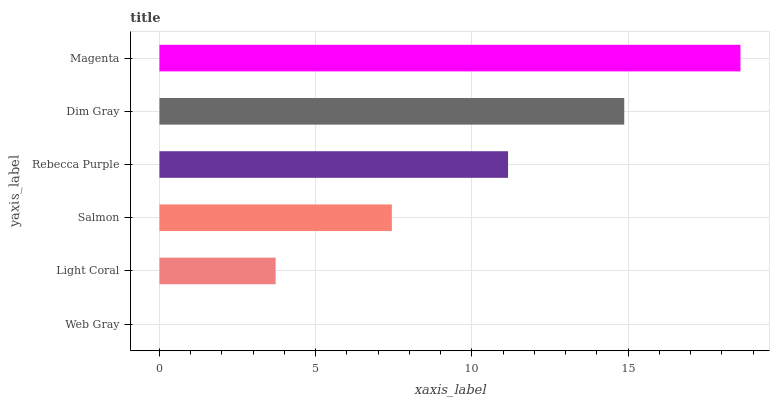Is Web Gray the minimum?
Answer yes or no. Yes. Is Magenta the maximum?
Answer yes or no. Yes. Is Light Coral the minimum?
Answer yes or no. No. Is Light Coral the maximum?
Answer yes or no. No. Is Light Coral greater than Web Gray?
Answer yes or no. Yes. Is Web Gray less than Light Coral?
Answer yes or no. Yes. Is Web Gray greater than Light Coral?
Answer yes or no. No. Is Light Coral less than Web Gray?
Answer yes or no. No. Is Rebecca Purple the high median?
Answer yes or no. Yes. Is Salmon the low median?
Answer yes or no. Yes. Is Dim Gray the high median?
Answer yes or no. No. Is Dim Gray the low median?
Answer yes or no. No. 